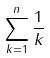<formula> <loc_0><loc_0><loc_500><loc_500>\sum _ { k = 1 } ^ { n } \frac { 1 } { k }</formula> 